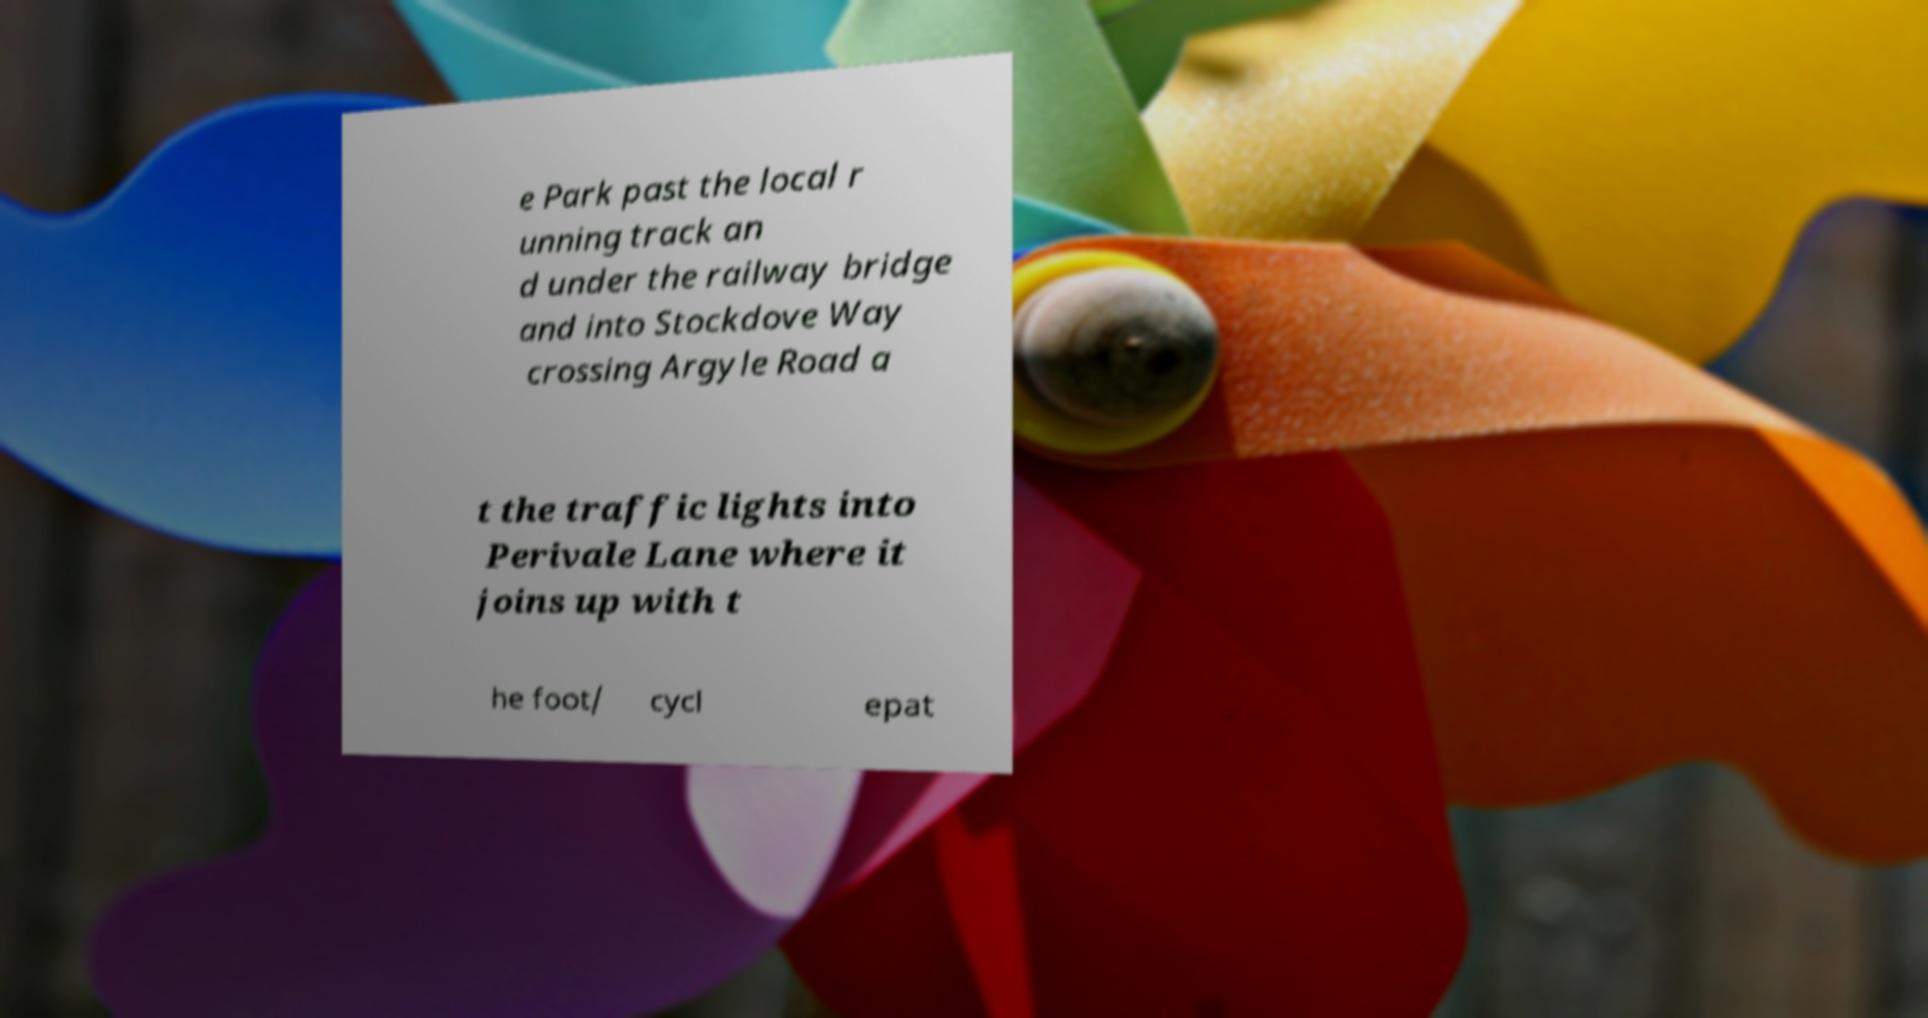Can you accurately transcribe the text from the provided image for me? e Park past the local r unning track an d under the railway bridge and into Stockdove Way crossing Argyle Road a t the traffic lights into Perivale Lane where it joins up with t he foot/ cycl epat 